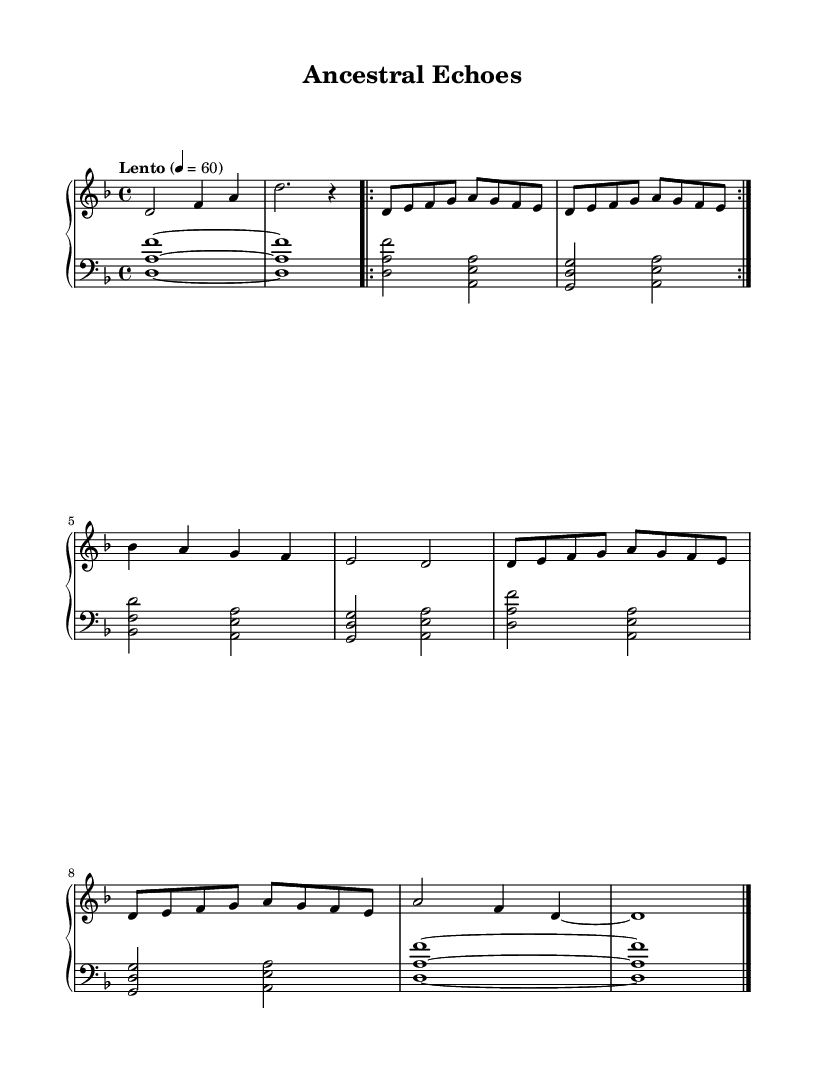What is the key signature of this music? The key signature is indicated at the beginning of the staff. In this case, there is one flat, which corresponds to the key of D minor.
Answer: D minor What is the time signature of this piece? The time signature is found at the beginning of the music, indicated by the fraction. Here, it is 4/4, which indicates four beats per measure.
Answer: 4/4 What is the tempo marking for this piece? The tempo marking is usually written above the staff, showing how fast the piece should be played. It states "Lento" with a metronome marking of 60 beats per minute.
Answer: Lento How many sections are repeated in the A section? The A section is marked by repeated musical phrases, specifically it has a repeat sign indicating that it is played twice. The question about the structure can be answered by counting the repeat marks.
Answer: 2 What type of musical accompaniment is indicated in the left hand? The left hand plays chords, which are indicated by stacks of notes, contrasting with the right hand melody. The harmonic texture provided by these chords fits the genre of ambient soundscapes.
Answer: Chords What is the last note of the piece? The last note is indicated in the "Outro" section of the music. The last note shown in the notation is a whole note D, marked with a barline to indicate the end of the music.
Answer: D What is the overall mood conveyed by the piece based on its tempo and dynamics? The overall mood is inferred from the slow tempo (Lento) and the soft dynamics typically associated with ambient music, designed for calm and focused listening. It promotes a contemplative atmosphere.
Answer: Calm 